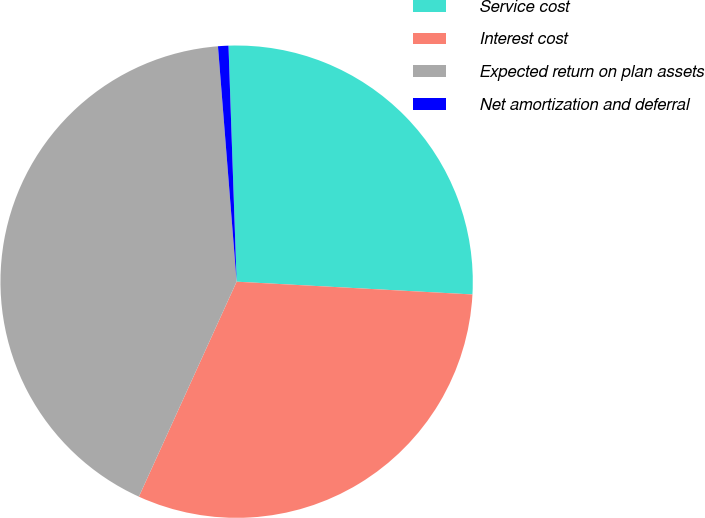Convert chart to OTSL. <chart><loc_0><loc_0><loc_500><loc_500><pie_chart><fcel>Service cost<fcel>Interest cost<fcel>Expected return on plan assets<fcel>Net amortization and deferral<nl><fcel>26.41%<fcel>30.93%<fcel>41.95%<fcel>0.71%<nl></chart> 